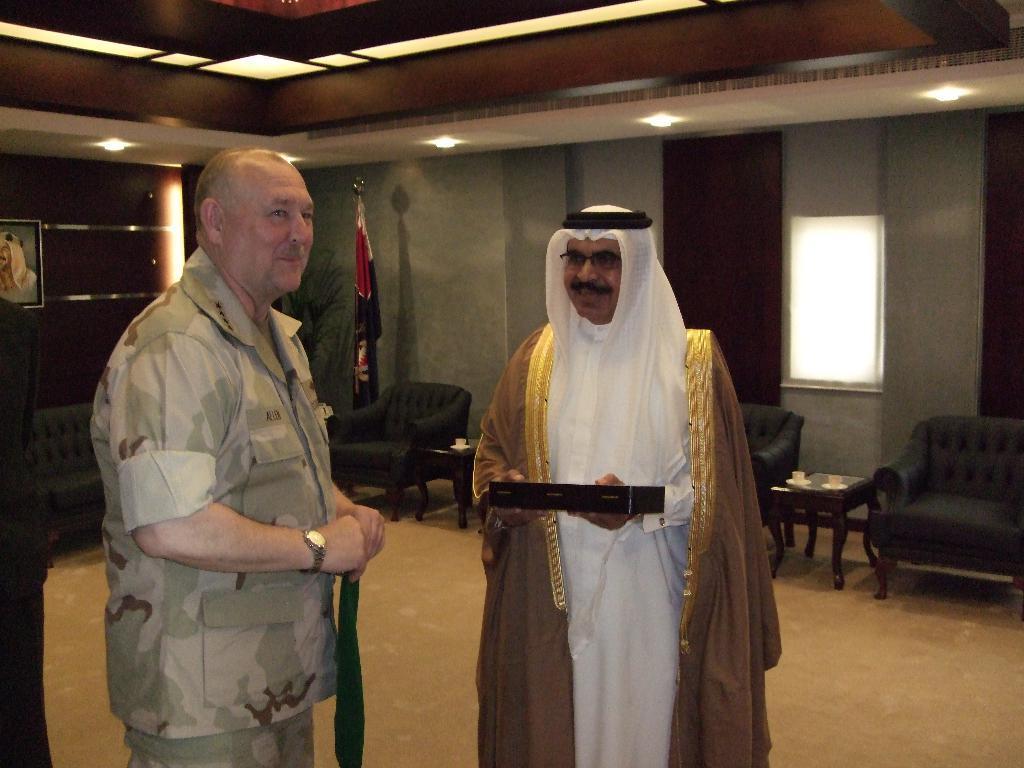Please provide a concise description of this image. These two persons standing. This person holding box. This is floor. We can see chairs and table. On the table we can see glass and saucer. On the background we can see wall,flag,frame. On the top we can see lights. 